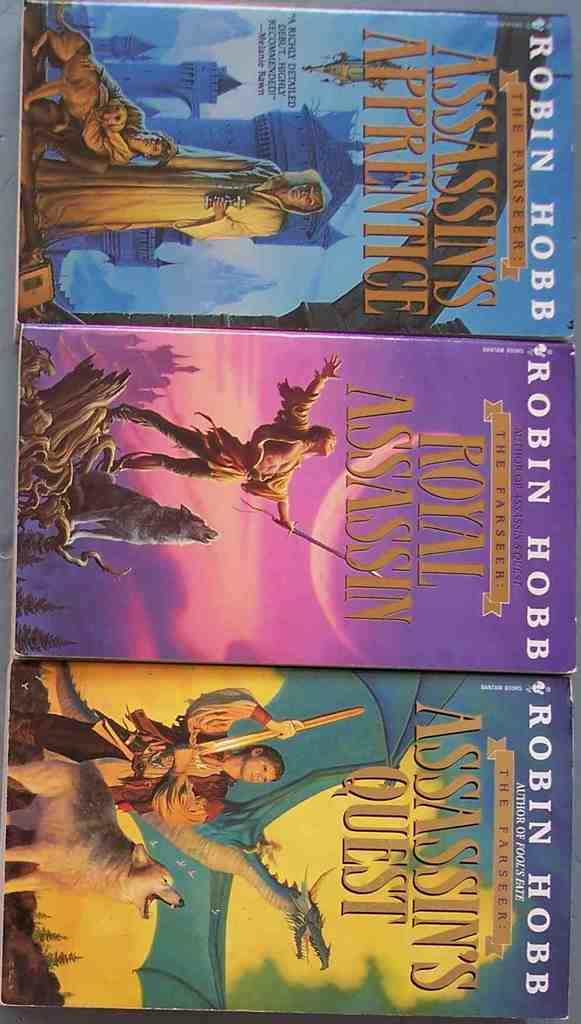<image>
Write a terse but informative summary of the picture. books by robin hobb in a row next to each other 